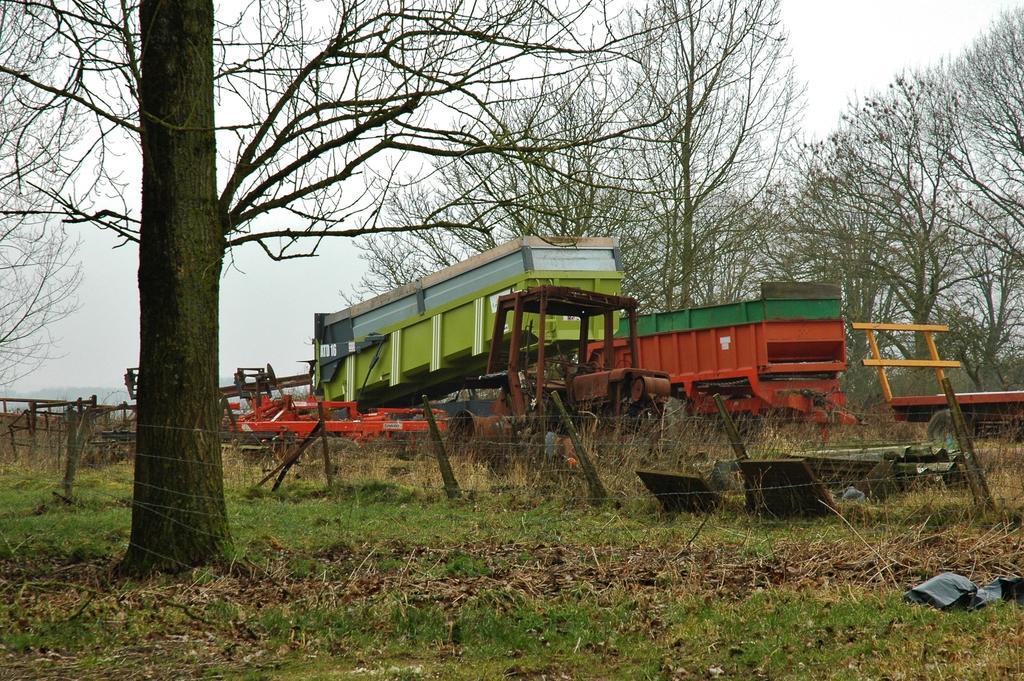Describe this image in one or two sentences. This picture might be taken from outside of the city. In this image, on the right side, we can see some vehicles and a tractor, trees. On the left side, we can see a net fence, trees. At the top, we can see a sky, at the bottom, we can see a grass. 